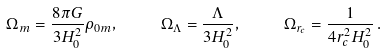<formula> <loc_0><loc_0><loc_500><loc_500>\Omega _ { m } = \frac { 8 \pi G } { 3 H _ { 0 } ^ { 2 } } \rho _ { 0 m } , \ \quad \Omega _ { \Lambda } = \frac { \Lambda } { 3 H _ { 0 } ^ { 2 } } , \ \quad \Omega _ { r _ { c } } = \frac { 1 } { 4 r _ { c } ^ { 2 } H _ { 0 } ^ { 2 } } \, .</formula> 